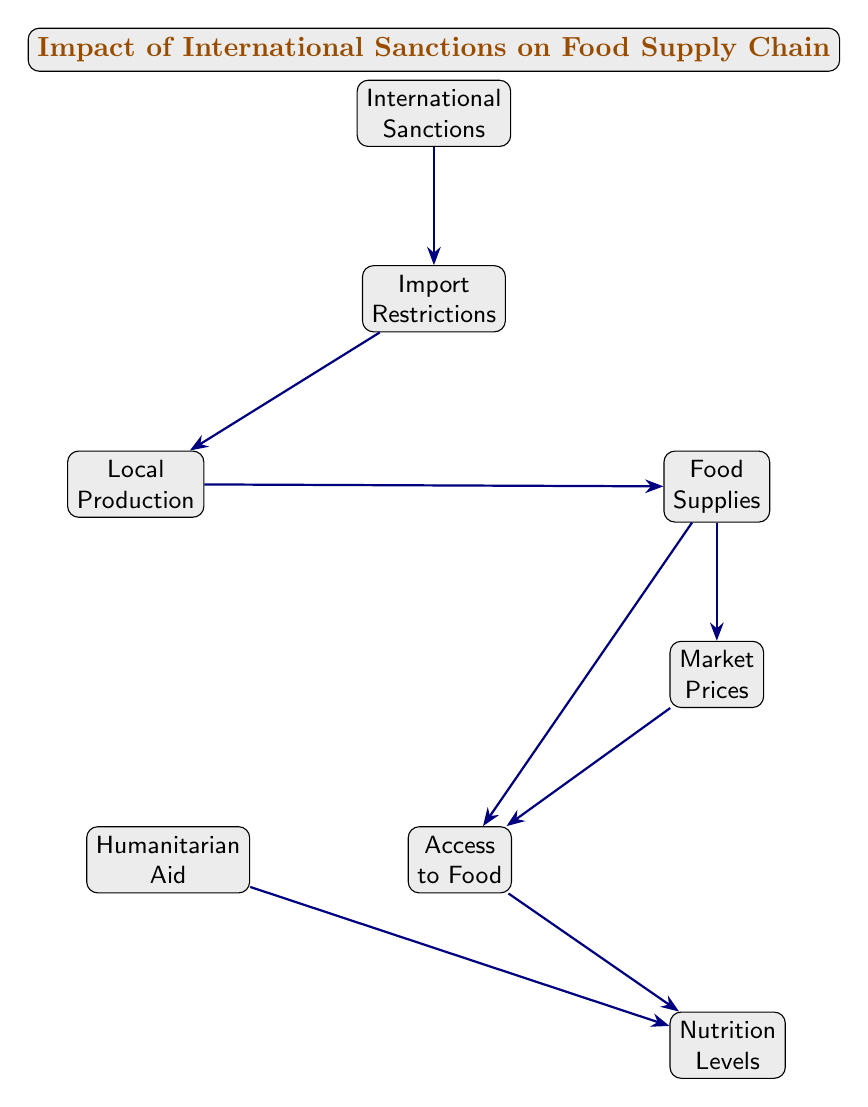What is the primary focus of the diagram? The diagram illustrates the effect of international sanctions on the food supply chain, emphasizing how sanctions influence various factors related to food availability and access.
Answer: Impact of International Sanctions on Food Supply Chain How many nodes are present in the diagram? The diagram consists of a total of seven nodes, which represent different components of the food supply chain affected by sanctions.
Answer: Seven What are the two nodes directly below "Food Supplies"? The two nodes located directly below "Food Supplies" are "Market Prices" and "Access to Food."
Answer: Market Prices, Access to Food What is the relationship between "Import Restrictions" and "Local Production"? "Import Restrictions" directly leads to "Local Production," indicating that restrictions on imports may encourage or necessitate increased local food production.
Answer: Direct Influence How do "Market Prices" influence "Access to Food"? "Market Prices" affects "Access to Food" as rising prices can limit access, making food less affordable for individuals.
Answer: Prices limit access What is the role of "Humanitarian Aid" in this diagram? "Humanitarian Aid" contributes to or supports "Nutrition Levels," indicating that aid can help improve nutritional status in conflict zones despite adverse conditions.
Answer: Support Nutrition Levels What nodes are connected to "Access to Food"? The nodes connected to "Access to Food" are "Market Prices," "Food Supplies," and "Nutrition Levels." This means access is influenced by both supply and pricing, impacting nutrition.
Answer: Market Prices, Food Supplies, Nutrition Levels Which node is the first affected by "International Sanctions"? "Import Restrictions" is the first node impacted by "International Sanctions," showing that sanctions primarily restrict imports.
Answer: Import Restrictions What is the ultimate outcome that the diagram depicts as a result of these interactions? The ultimate outcome depicted is "Nutrition Levels," showing that the supply chain's dynamics ultimately affect the nutritional well-being of individuals in conflict zones.
Answer: Nutrition Levels 